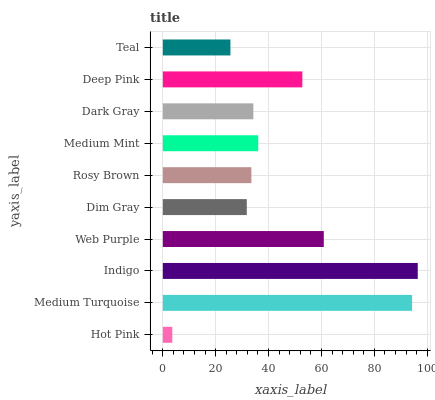Is Hot Pink the minimum?
Answer yes or no. Yes. Is Indigo the maximum?
Answer yes or no. Yes. Is Medium Turquoise the minimum?
Answer yes or no. No. Is Medium Turquoise the maximum?
Answer yes or no. No. Is Medium Turquoise greater than Hot Pink?
Answer yes or no. Yes. Is Hot Pink less than Medium Turquoise?
Answer yes or no. Yes. Is Hot Pink greater than Medium Turquoise?
Answer yes or no. No. Is Medium Turquoise less than Hot Pink?
Answer yes or no. No. Is Medium Mint the high median?
Answer yes or no. Yes. Is Dark Gray the low median?
Answer yes or no. Yes. Is Indigo the high median?
Answer yes or no. No. Is Hot Pink the low median?
Answer yes or no. No. 